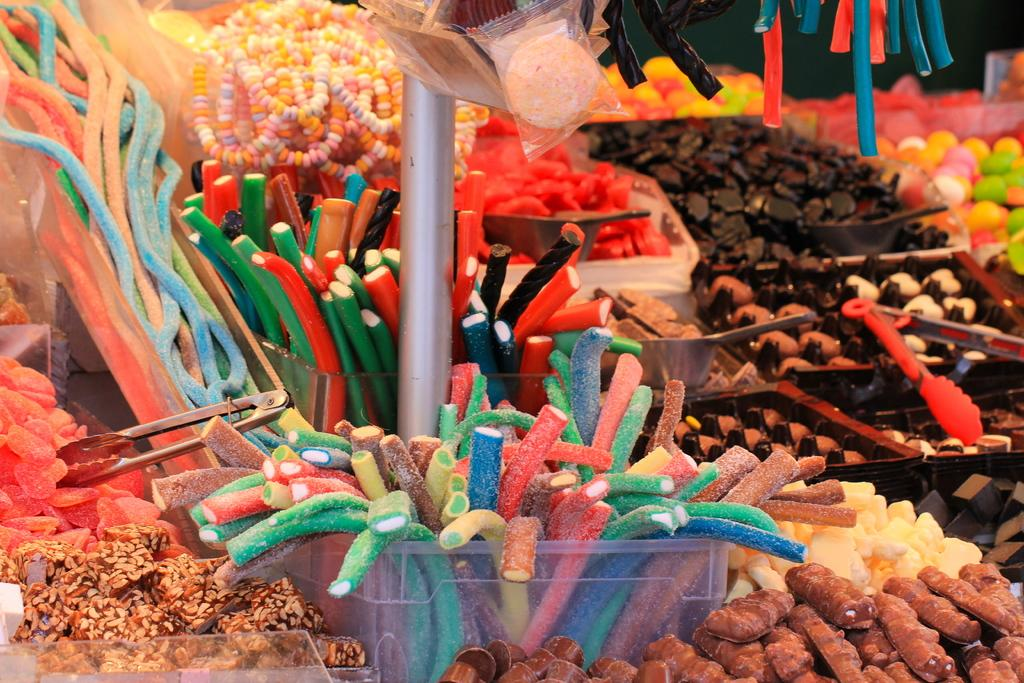What type of sweets can be seen in the image? There are candies in the image, specifically sugar candies. What objects are present to hold or display the candies? There are holders and a stand in the image. How are the candies arranged or presented in the image? The candies are arranged on trays in the image. Can you see a donkey wearing a cent suit in the image? No, there is no donkey or cent suit present in the image. 